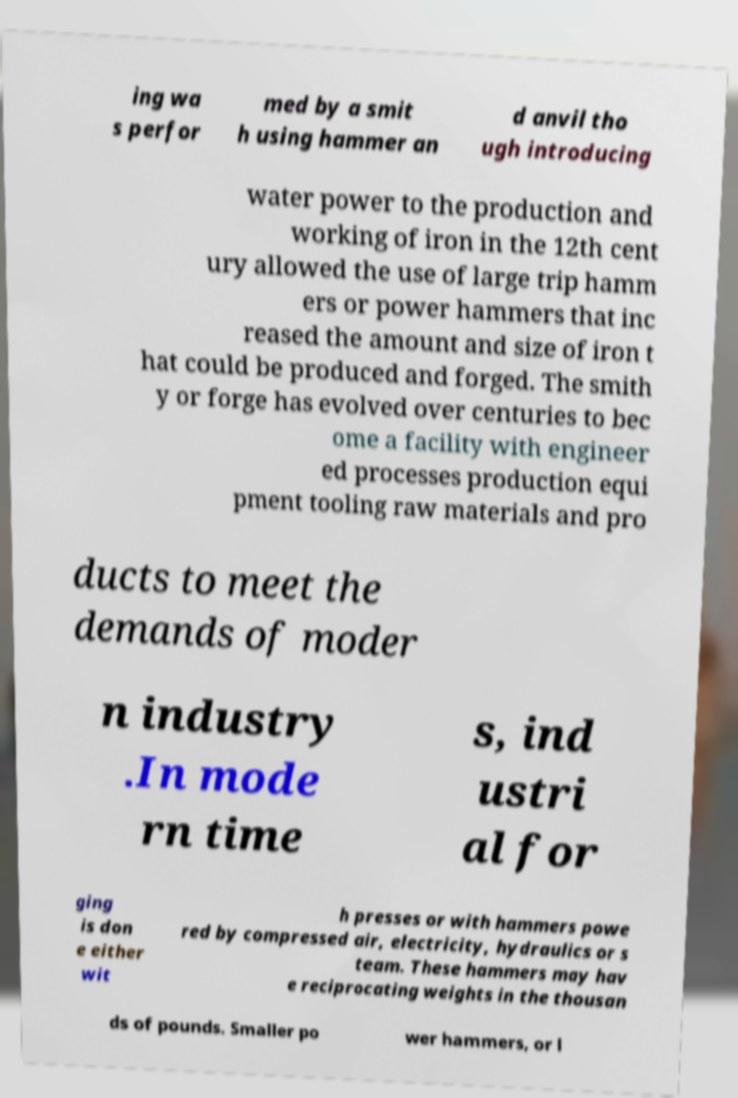Could you assist in decoding the text presented in this image and type it out clearly? ing wa s perfor med by a smit h using hammer an d anvil tho ugh introducing water power to the production and working of iron in the 12th cent ury allowed the use of large trip hamm ers or power hammers that inc reased the amount and size of iron t hat could be produced and forged. The smith y or forge has evolved over centuries to bec ome a facility with engineer ed processes production equi pment tooling raw materials and pro ducts to meet the demands of moder n industry .In mode rn time s, ind ustri al for ging is don e either wit h presses or with hammers powe red by compressed air, electricity, hydraulics or s team. These hammers may hav e reciprocating weights in the thousan ds of pounds. Smaller po wer hammers, or l 